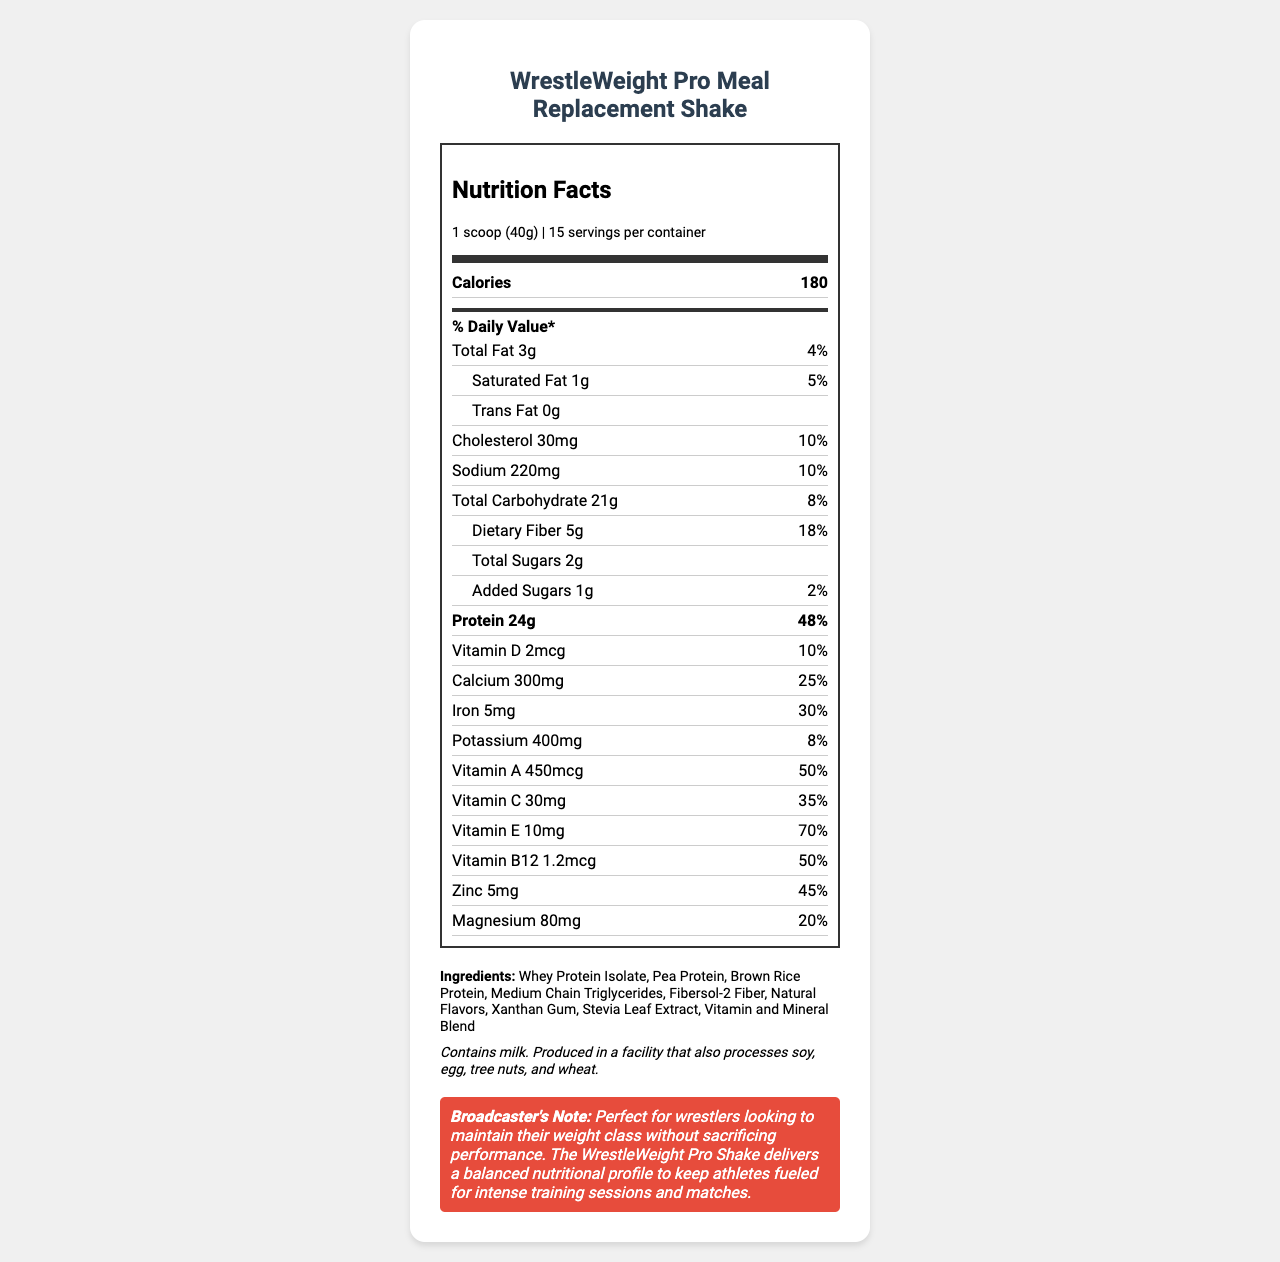what is the serving size? The serving size is mentioned in the document's nutrition facts section as "1 scoop (40g)".
Answer: 1 scoop (40g) how many calories are in one serving of WrestleWeight Pro Meal Replacement Shake? The document states that there are 180 calories per serving.
Answer: 180 what is the amount of protein per serving? The amount of protein per serving is given as 24g in the nutrition facts.
Answer: 24g how much sodium does one serving contain? According to the document, each serving contains 220mg of sodium.
Answer: 220mg how much dietary fiber is in one serving? The dietary fiber content per serving is specified as 5g.
Answer: 5g how many servings are there per container? A. 10 B. 12 C. 15 D. 18 The document states there are 15 servings per container.
Answer: C what percentage of the daily value of calcium does one serving provide? A. 5% B. 10% C. 20% D. 25% Each serving provides 25% of the daily value for calcium as per the document.
Answer: D does the meal replacement shake contain any trans fats? The document clearly states "Trans Fat 0g", meaning there are no trans fats in the shake.
Answer: No is this product suitable for wrestlers looking to maintain their weight class? The broadcaster’s note specifies that this product is perfect for wrestlers looking to maintain their weight class.
Answer: Yes summarize the main idea of the document. The document provides a comprehensive view of the product's nutrition facts, showing that it is low in calories and fat, high in protein, and includes numerous essential vitamins and minerals, making it ideal for wrestlers.
Answer: The document details the nutrition facts of WrestleWeight Pro Meal Replacement Shake, highlighting its suitability for wrestlers managing weight. It provides a detailed breakdown of macronutrients, minerals, vitamins, and ingredients, emphasizing its high protein content and balanced nutritional profile. what is the manufacturing location of the WrestleWeight Pro Meal Replacement Shake? The document does not provide any details about the manufacturing location.
Answer: Not enough information what type of protein sources are included in the ingredients list? The ingredients list specifies three protein sources: Whey Protein Isolate, Pea Protein, and Brown Rice Protein.
Answer: Whey Protein Isolate, Pea Protein, Brown Rice Protein how much sugar is added to the shake? The document notes that there is 1g of added sugars per serving.
Answer: 1g what is the purpose of Xanthan Gum in the ingredients? The document lists Xanthan Gum as an ingredient but does not provide its purpose or function in the shake.
Answer: Cannot be determined how much Vitamin E is in each serving? The amount of Vitamin E per serving is 10mg as detailed in the nutrition facts section.
Answer: 10mg does this product contain any allergens? If so, what are they? The allergen information section states that the product contains milk.
Answer: Yes, contains milk 